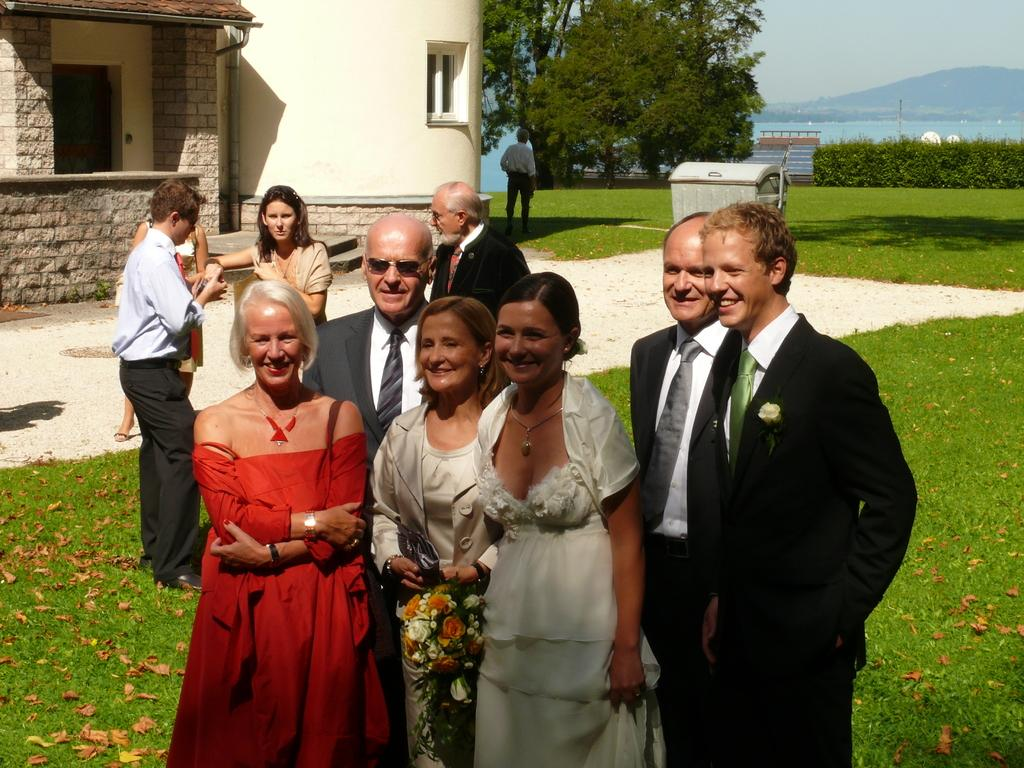What types of people are present in the image? There are men and women standing in the image. What natural elements can be seen in the image? There are trees and grass in the image. What type of structure is visible in the image? There is a building in the image. What type of trousers are the government officials wearing in the image? There is no indication in the image that the people present are government officials, nor is there any information about their clothing. 